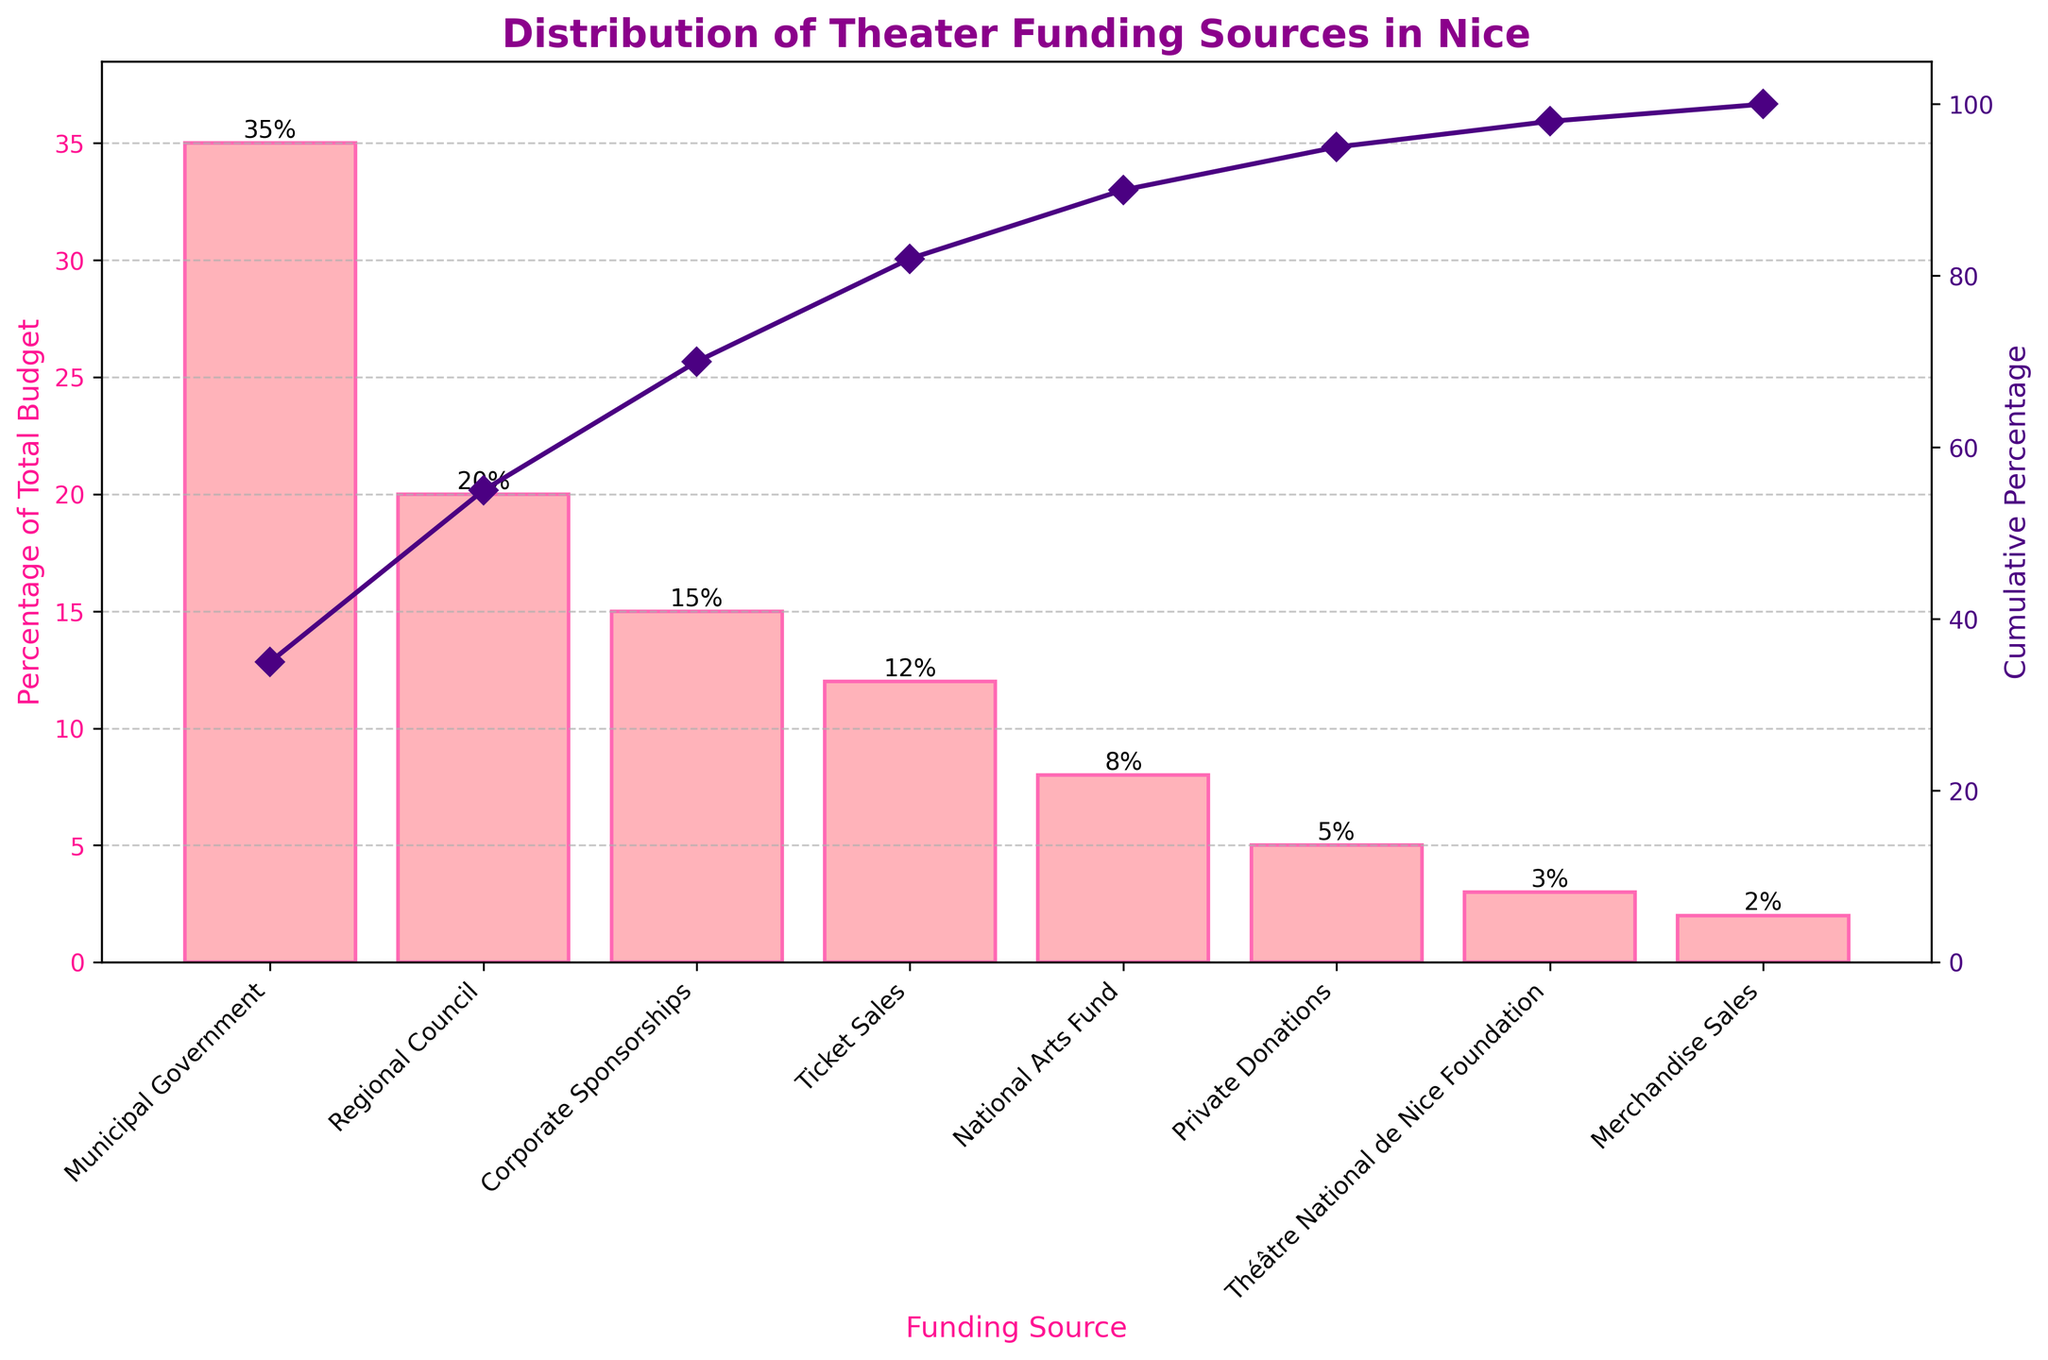What's the title of the plot? The title of the plot is displayed prominently at the top.
Answer: Distribution of Theater Funding Sources in Nice Which funding source has the highest percentage of the total budget? The bar representing 'Municipal Government' is the tallest, indicating it has the highest percentage.
Answer: Municipal Government What's the cumulative percentage for Regional Council? Follow the cumulative line until it intersects with the Regional Council mark.
Answer: 55% What's the combined percentage for Ticket Sales and Private Donations? Add the percentage values for Ticket Sales (12%) and Private Donations (5%).
Answer: 17% Which funding source has the lowest percentage of the total budget? The shortest bar represents 'Merchandise Sales.'
Answer: Merchandise Sales What is the cumulative percentage after including Corporate Sponsorships? Find the point on the cumulative line above Corporate Sponsorships (15%) and read its value.
Answer: 70% What's the difference in percentage between Corporate Sponsorships and National Arts Fund? Subtract the percentage of National Arts Fund (8%) from Corporate Sponsorships (15%).
Answer: 7% How does the cumulative percentage change from Private Donations to Merchandise Sales? Compare the cumulative percentages above Private Donations and Merchandise Sales.
Answer: Increases by 2% What percentage of the total budget comes from private sources (Corporate Sponsorships, Private Donations, Merchandise Sales)? Sum the percentages for Corporate Sponsorships (15%), Private Donations (5%), and Merchandise Sales (2%).
Answer: 22% Is the cumulative percentage more or less than 50% after adding up Ticket Sales? Find the cumulative value after Ticket Sales (12%) and compare it with 50%.
Answer: Less 